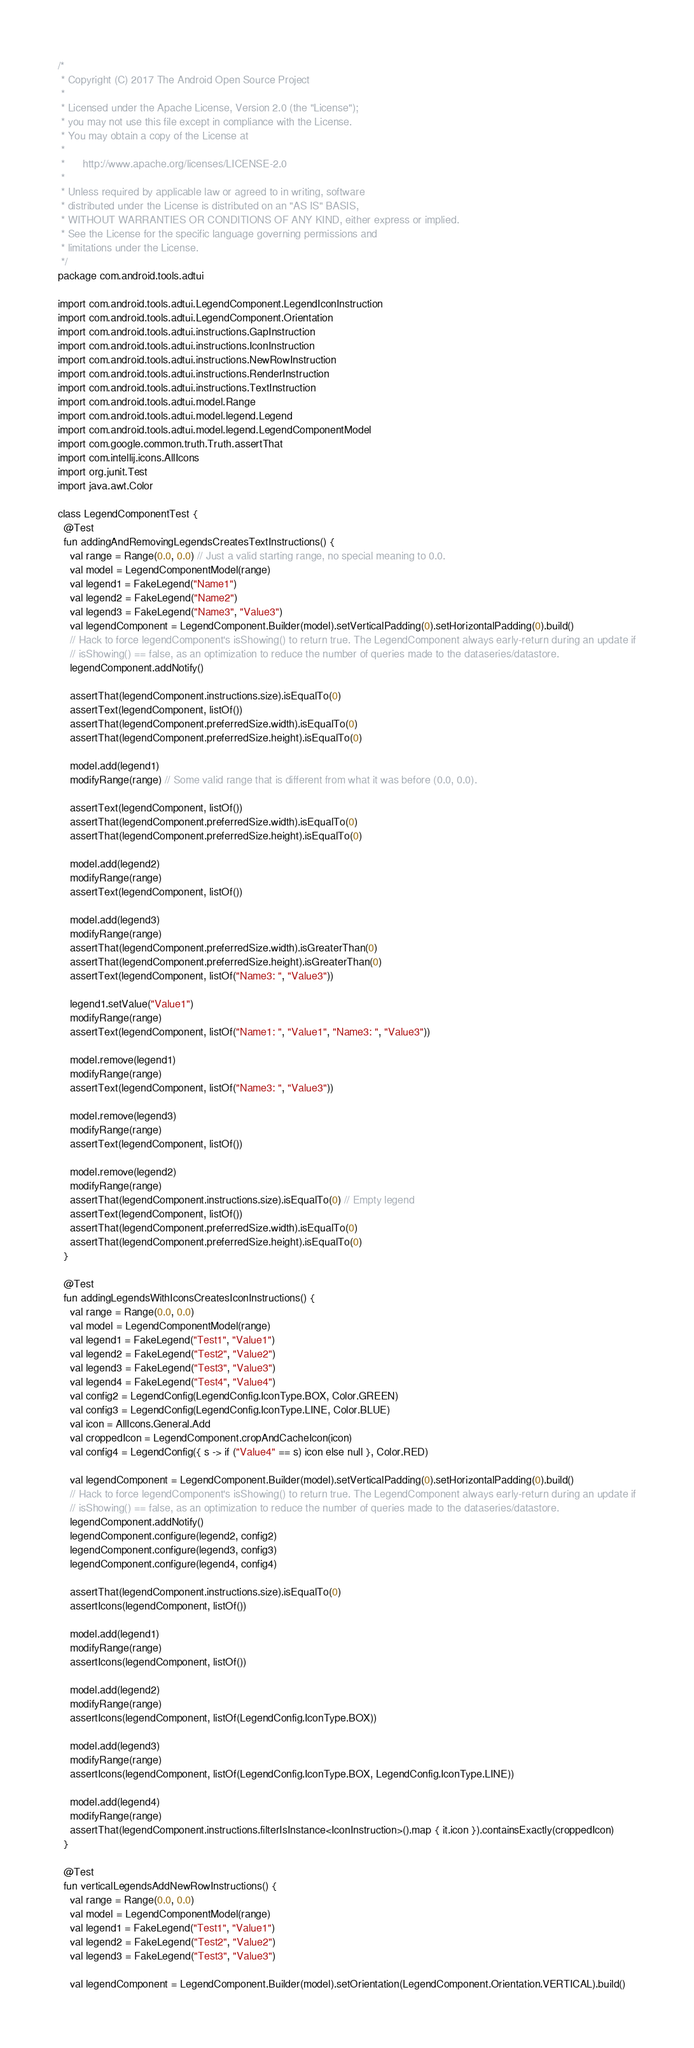Convert code to text. <code><loc_0><loc_0><loc_500><loc_500><_Kotlin_>/*
 * Copyright (C) 2017 The Android Open Source Project
 *
 * Licensed under the Apache License, Version 2.0 (the "License");
 * you may not use this file except in compliance with the License.
 * You may obtain a copy of the License at
 *
 *      http://www.apache.org/licenses/LICENSE-2.0
 *
 * Unless required by applicable law or agreed to in writing, software
 * distributed under the License is distributed on an "AS IS" BASIS,
 * WITHOUT WARRANTIES OR CONDITIONS OF ANY KIND, either express or implied.
 * See the License for the specific language governing permissions and
 * limitations under the License.
 */
package com.android.tools.adtui

import com.android.tools.adtui.LegendComponent.LegendIconInstruction
import com.android.tools.adtui.LegendComponent.Orientation
import com.android.tools.adtui.instructions.GapInstruction
import com.android.tools.adtui.instructions.IconInstruction
import com.android.tools.adtui.instructions.NewRowInstruction
import com.android.tools.adtui.instructions.RenderInstruction
import com.android.tools.adtui.instructions.TextInstruction
import com.android.tools.adtui.model.Range
import com.android.tools.adtui.model.legend.Legend
import com.android.tools.adtui.model.legend.LegendComponentModel
import com.google.common.truth.Truth.assertThat
import com.intellij.icons.AllIcons
import org.junit.Test
import java.awt.Color

class LegendComponentTest {
  @Test
  fun addingAndRemovingLegendsCreatesTextInstructions() {
    val range = Range(0.0, 0.0) // Just a valid starting range, no special meaning to 0.0.
    val model = LegendComponentModel(range)
    val legend1 = FakeLegend("Name1")
    val legend2 = FakeLegend("Name2")
    val legend3 = FakeLegend("Name3", "Value3")
    val legendComponent = LegendComponent.Builder(model).setVerticalPadding(0).setHorizontalPadding(0).build()
    // Hack to force legendComponent's isShowing() to return true. The LegendComponent always early-return during an update if
    // isShowing() == false, as an optimization to reduce the number of queries made to the dataseries/datastore.
    legendComponent.addNotify()

    assertThat(legendComponent.instructions.size).isEqualTo(0)
    assertText(legendComponent, listOf())
    assertThat(legendComponent.preferredSize.width).isEqualTo(0)
    assertThat(legendComponent.preferredSize.height).isEqualTo(0)

    model.add(legend1)
    modifyRange(range) // Some valid range that is different from what it was before (0.0, 0.0).

    assertText(legendComponent, listOf())
    assertThat(legendComponent.preferredSize.width).isEqualTo(0)
    assertThat(legendComponent.preferredSize.height).isEqualTo(0)

    model.add(legend2)
    modifyRange(range)
    assertText(legendComponent, listOf())

    model.add(legend3)
    modifyRange(range)
    assertThat(legendComponent.preferredSize.width).isGreaterThan(0)
    assertThat(legendComponent.preferredSize.height).isGreaterThan(0)
    assertText(legendComponent, listOf("Name3: ", "Value3"))

    legend1.setValue("Value1")
    modifyRange(range)
    assertText(legendComponent, listOf("Name1: ", "Value1", "Name3: ", "Value3"))

    model.remove(legend1)
    modifyRange(range)
    assertText(legendComponent, listOf("Name3: ", "Value3"))

    model.remove(legend3)
    modifyRange(range)
    assertText(legendComponent, listOf())

    model.remove(legend2)
    modifyRange(range)
    assertThat(legendComponent.instructions.size).isEqualTo(0) // Empty legend
    assertText(legendComponent, listOf())
    assertThat(legendComponent.preferredSize.width).isEqualTo(0)
    assertThat(legendComponent.preferredSize.height).isEqualTo(0)
  }

  @Test
  fun addingLegendsWithIconsCreatesIconInstructions() {
    val range = Range(0.0, 0.0)
    val model = LegendComponentModel(range)
    val legend1 = FakeLegend("Test1", "Value1")
    val legend2 = FakeLegend("Test2", "Value2")
    val legend3 = FakeLegend("Test3", "Value3")
    val legend4 = FakeLegend("Test4", "Value4")
    val config2 = LegendConfig(LegendConfig.IconType.BOX, Color.GREEN)
    val config3 = LegendConfig(LegendConfig.IconType.LINE, Color.BLUE)
    val icon = AllIcons.General.Add
    val croppedIcon = LegendComponent.cropAndCacheIcon(icon)
    val config4 = LegendConfig({ s -> if ("Value4" == s) icon else null }, Color.RED)

    val legendComponent = LegendComponent.Builder(model).setVerticalPadding(0).setHorizontalPadding(0).build()
    // Hack to force legendComponent's isShowing() to return true. The LegendComponent always early-return during an update if
    // isShowing() == false, as an optimization to reduce the number of queries made to the dataseries/datastore.
    legendComponent.addNotify()
    legendComponent.configure(legend2, config2)
    legendComponent.configure(legend3, config3)
    legendComponent.configure(legend4, config4)

    assertThat(legendComponent.instructions.size).isEqualTo(0)
    assertIcons(legendComponent, listOf())

    model.add(legend1)
    modifyRange(range)
    assertIcons(legendComponent, listOf())

    model.add(legend2)
    modifyRange(range)
    assertIcons(legendComponent, listOf(LegendConfig.IconType.BOX))

    model.add(legend3)
    modifyRange(range)
    assertIcons(legendComponent, listOf(LegendConfig.IconType.BOX, LegendConfig.IconType.LINE))

    model.add(legend4)
    modifyRange(range)
    assertThat(legendComponent.instructions.filterIsInstance<IconInstruction>().map { it.icon }).containsExactly(croppedIcon)
  }

  @Test
  fun verticalLegendsAddNewRowInstructions() {
    val range = Range(0.0, 0.0)
    val model = LegendComponentModel(range)
    val legend1 = FakeLegend("Test1", "Value1")
    val legend2 = FakeLegend("Test2", "Value2")
    val legend3 = FakeLegend("Test3", "Value3")

    val legendComponent = LegendComponent.Builder(model).setOrientation(LegendComponent.Orientation.VERTICAL).build()</code> 